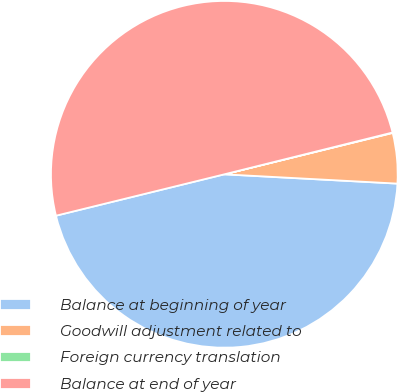Convert chart. <chart><loc_0><loc_0><loc_500><loc_500><pie_chart><fcel>Balance at beginning of year<fcel>Goodwill adjustment related to<fcel>Foreign currency translation<fcel>Balance at end of year<nl><fcel>45.31%<fcel>4.69%<fcel>0.04%<fcel>49.96%<nl></chart> 